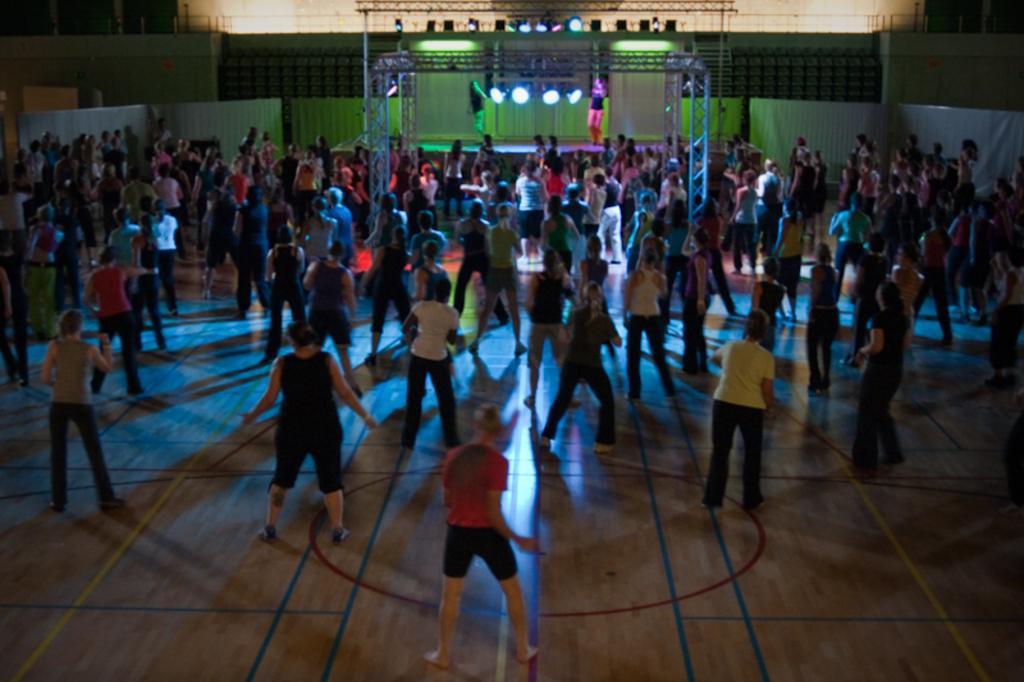Describe this image in one or two sentences. In this picture we can see many peoples were dancing. In the background we can see the focus lights and stage. There are two women were dancing on on the stage. 